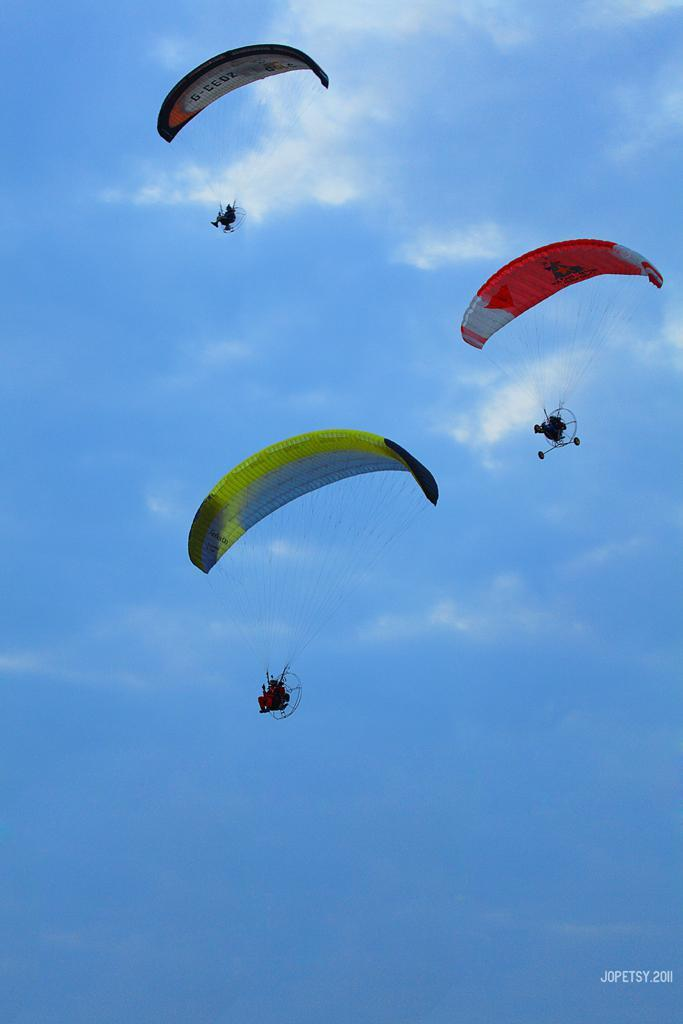What activity are the people in the image participating in? The people in the image are doing paragliding. Where are the people located in the image? The people are in the air. What can be seen in the sky in the image? There are clouds visible in the image. Is there any text or marking at the bottom right corner of the image? Yes, there is a watermark at the right bottom of the image. What type of bridge can be seen connecting the two paragliders in the image? There is no bridge connecting the two paragliders in the image; they are simply flying in the air. What kind of structure is holding the paragliders up in the image? The paragliders are not attached to any structure; they are supported by the paragliding equipment they are wearing. 